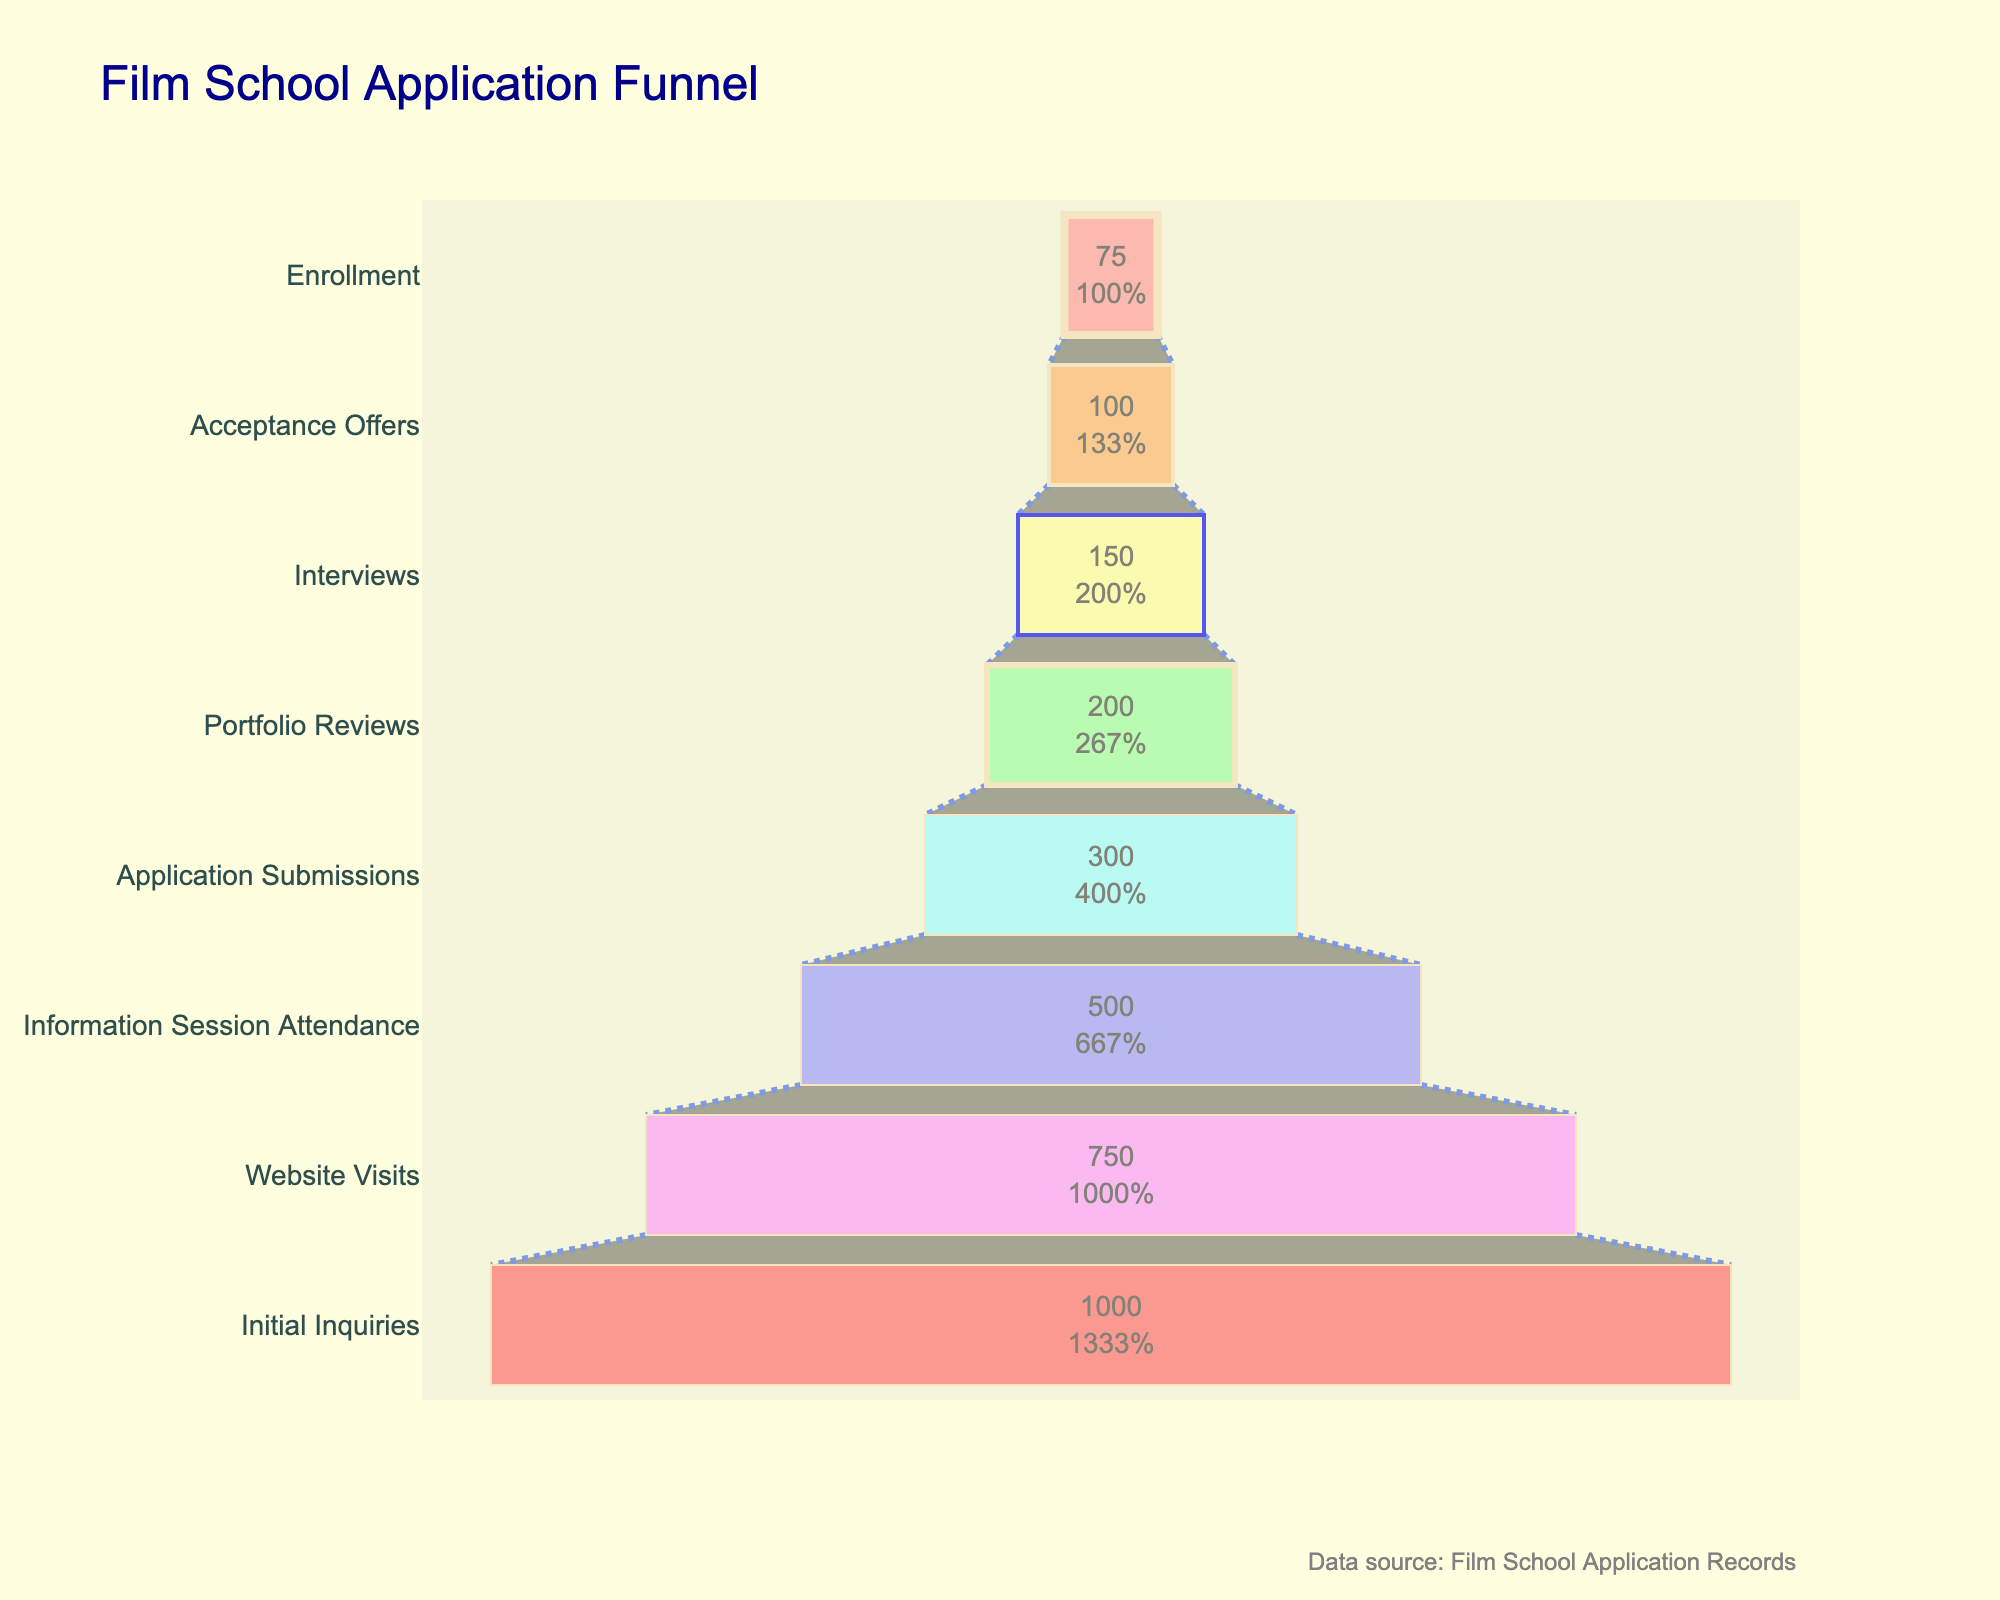What's the title of the figure? The title of the figure is located at the very top and is often in larger or bold text to stand out. In this case, it is mentioned as 'Film School Application Funnel'.
Answer: Film School Application Funnel What is the first stage listed at the bottom of the funnel? The stages in a funnel chart are typically listed from top to bottom in the order of the process. Therefore, the first stage listed at the bottom would be the final stage of the process.
Answer: Enrollment How many applicants attended the information session? Locate the bar labeled 'Information Session Attendance' within the funnel chart. The number displayed within the bar indicates the number of applicants.
Answer: 500 Which stage experienced the largest drop in applicant numbers? To find the largest drop, compare the difference in applicant numbers between consecutive stages and identify the greatest reduction.
Answer: Initial Inquiries to Website Visits What fraction of the initial inquiries ended up enrolling? From the funnel, you can see that the initial inquiries were 1000, and the enrollments were 75. To find the fraction, use the formula 75/1000.
Answer: 75/1000 or 7.5% Which two stages have the closest number of applicants? By visually inspecting the lengths of the bars in the funnel, identify two consecutive stages with the closest lengths (applicant numbers).
Answer: Interviews and Acceptance Offers What percentage of applicants who submitted portfolios ended up enrolling? First, determine the number of applicants who passed the 'Portfolio Reviews' stage (200). Then, find the number of applicants enrolled (75). Calculate the percentage as (75/200) * 100.
Answer: 37.5% Compare the attrition rate between the 'Application Submissions' and 'Portfolio Reviews' stages to the 'Interviews' and 'Acceptance Offers' stages. Which has a higher attrition rate? Calculate attrition rates: For 'Application Submissions' (300) to 'Portfolio Reviews' (200): ((300 - 200) / 300) * 100 = 33.33%. For 'Interviews' (150) to 'Acceptance Offers' (100): ((150 - 100) / 150) * 100 = 33.33%. Both attrition rates are the same at 33.33%.
Answer: Both are the same 